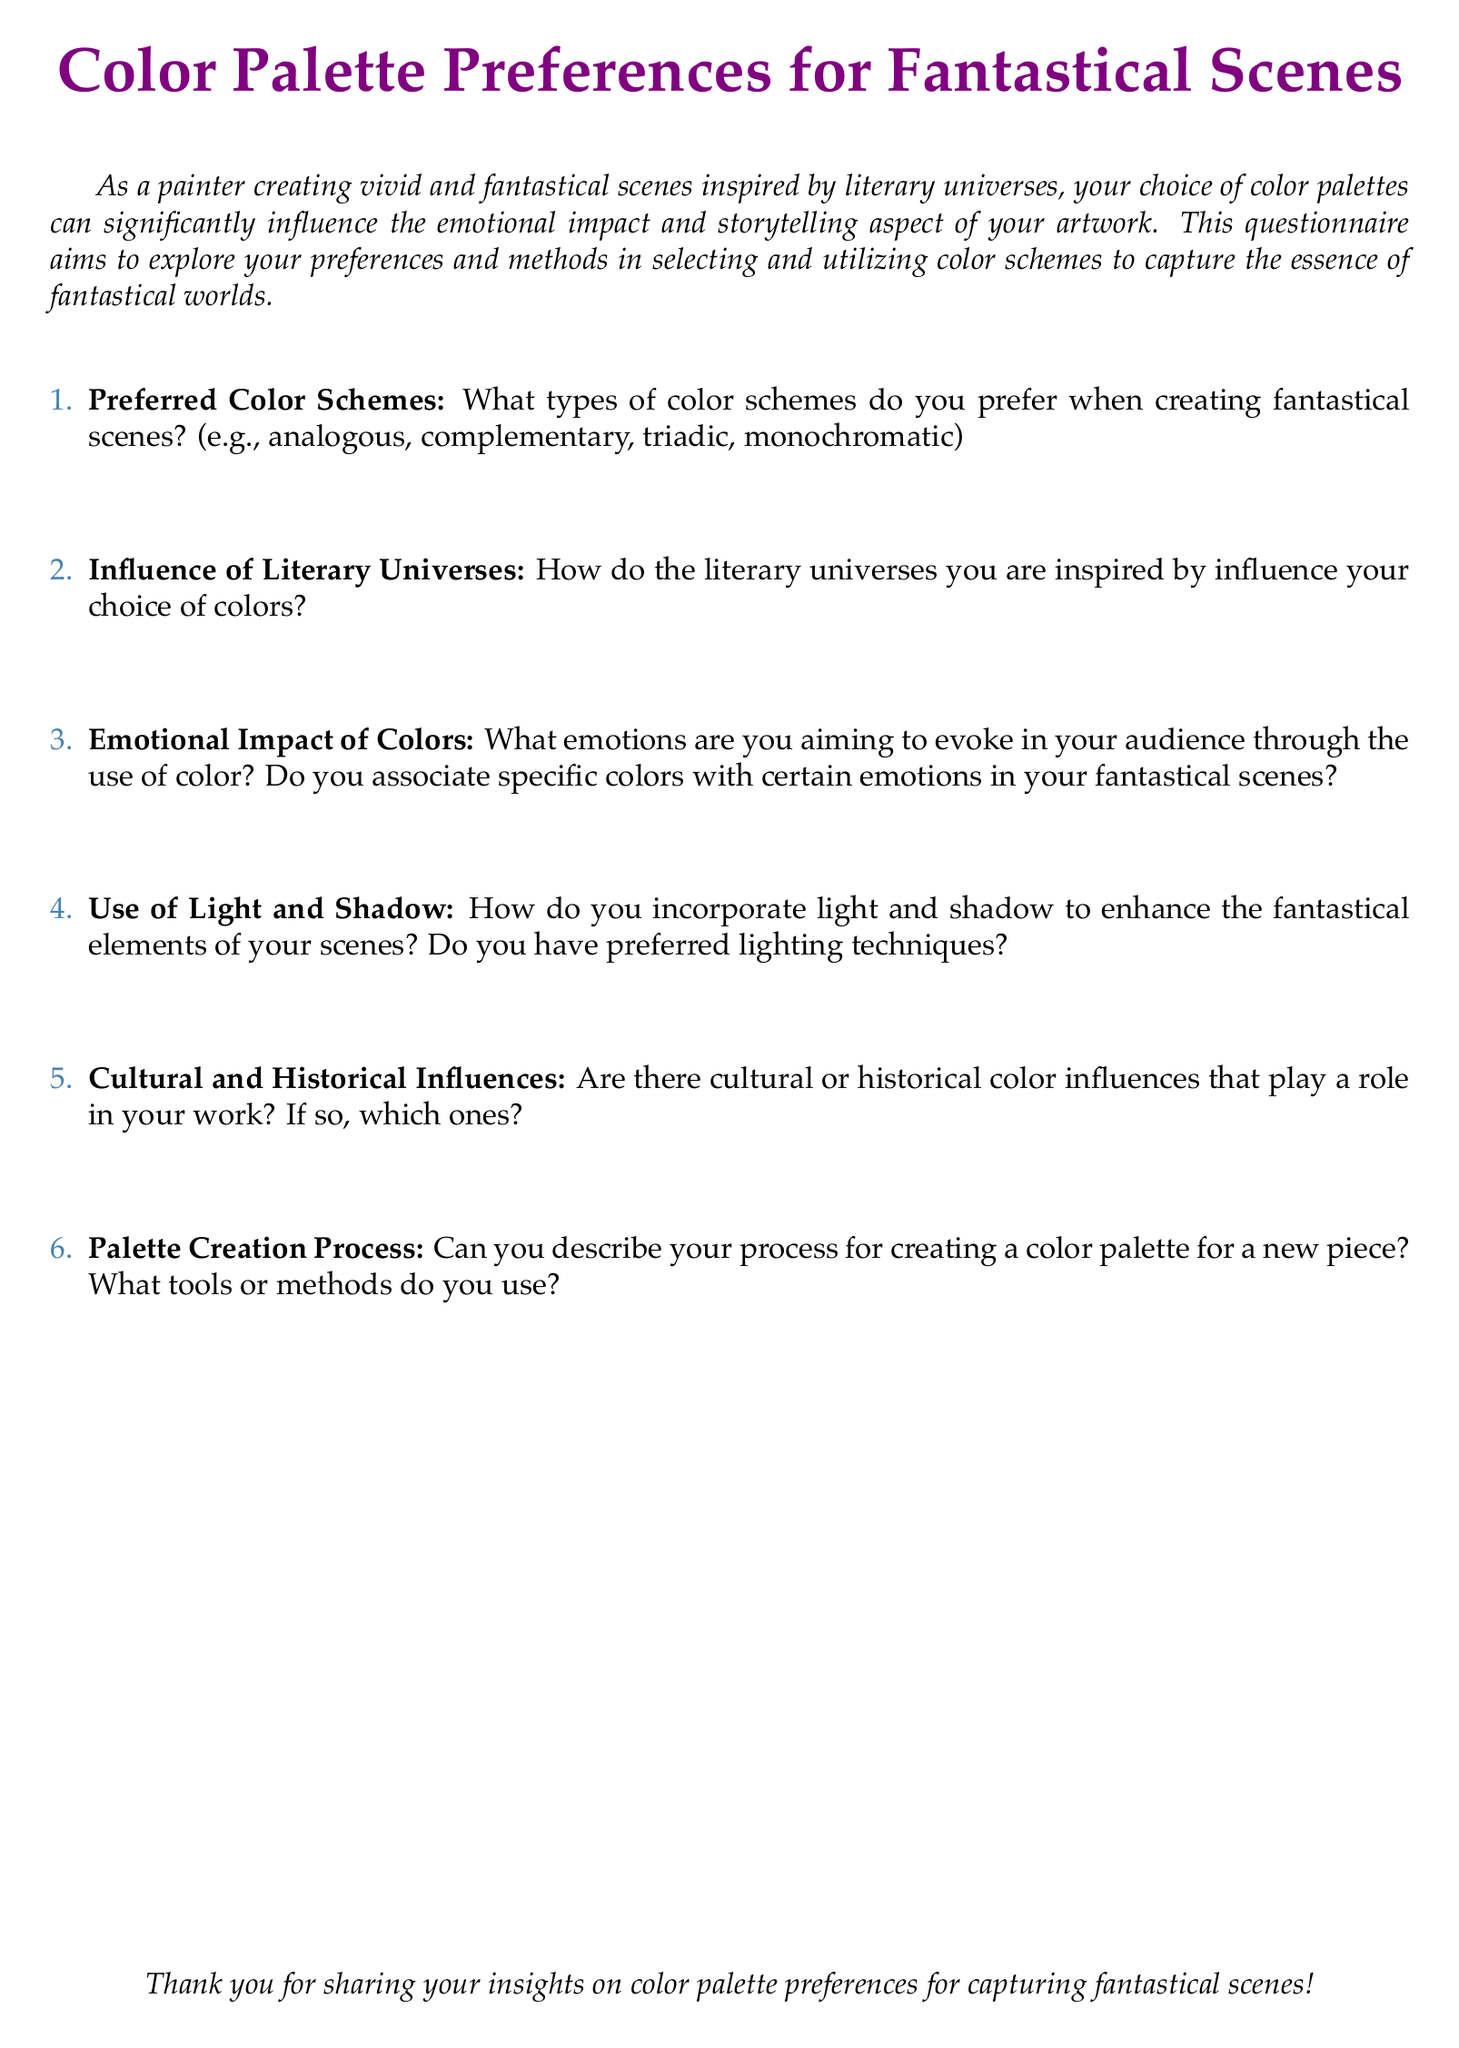What is the title of the document? The title is presented prominently at the beginning of the document, highlighting the focus on color palettes.
Answer: Color Palette Preferences for Fantastical Scenes What color is used for the main title text? The document specifies the color used for the main title, which enhances its visual appeal.
Answer: fantasypurple How many questions are included in the questionnaire? The number of questions can be counted easily in the enumerated list presented in the document.
Answer: 6 What type of color schemes does the questionnaire ask about? The questionnaire specifies various color schemes that the artist might use.
Answer: analogous, complementary, triadic, monochromatic What do the questions in the document aim to explore? The focus of the questions is on the artist's preferences and methods regarding color schemes.
Answer: Preferences and methods in selecting color schemes What is the main font used in the document? The document mentions the font used for text, which affects readability and overall aesthetic.
Answer: Palatino 